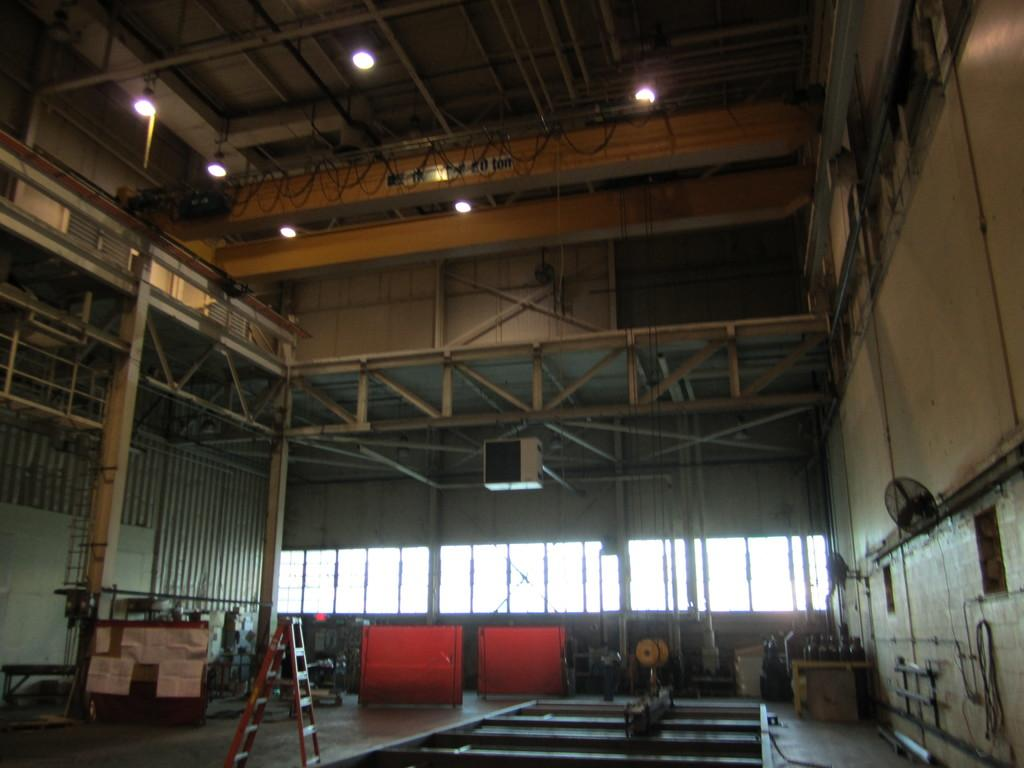What is the main object in the image? There is a ladder in the image. What else can be seen on the floor in the image? There are other things on the floor in the image. What is located on the roof in the image? There are lights on the roof in the image. How does the ladder contribute to reducing pollution in the image? The ladder does not contribute to reducing pollution in the image, as it is an object and not a factor in pollution reduction. 